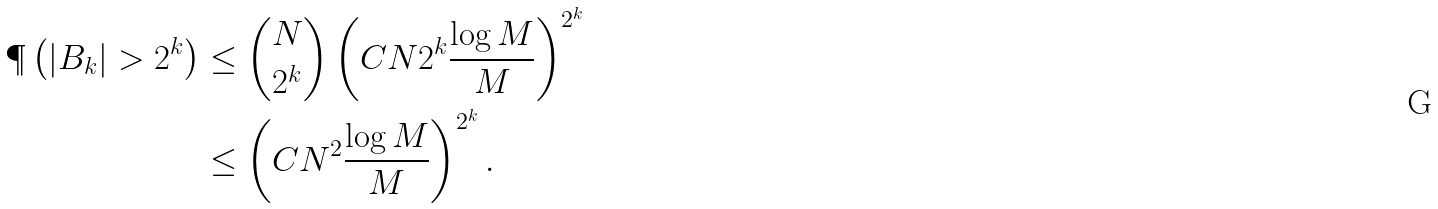<formula> <loc_0><loc_0><loc_500><loc_500>\P \left ( | B _ { k } | > 2 ^ { k } \right ) & \leq \binom { N } { 2 ^ { k } } \left ( C N 2 ^ { k } \frac { \log M } { M } \right ) ^ { 2 ^ { k } } \\ & \leq \left ( C N ^ { 2 } \frac { \log M } { M } \right ) ^ { 2 ^ { k } } .</formula> 